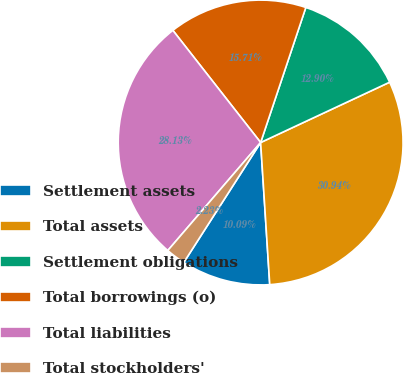<chart> <loc_0><loc_0><loc_500><loc_500><pie_chart><fcel>Settlement assets<fcel>Total assets<fcel>Settlement obligations<fcel>Total borrowings (o)<fcel>Total liabilities<fcel>Total stockholders'<nl><fcel>10.09%<fcel>30.94%<fcel>12.9%<fcel>15.71%<fcel>28.13%<fcel>2.23%<nl></chart> 